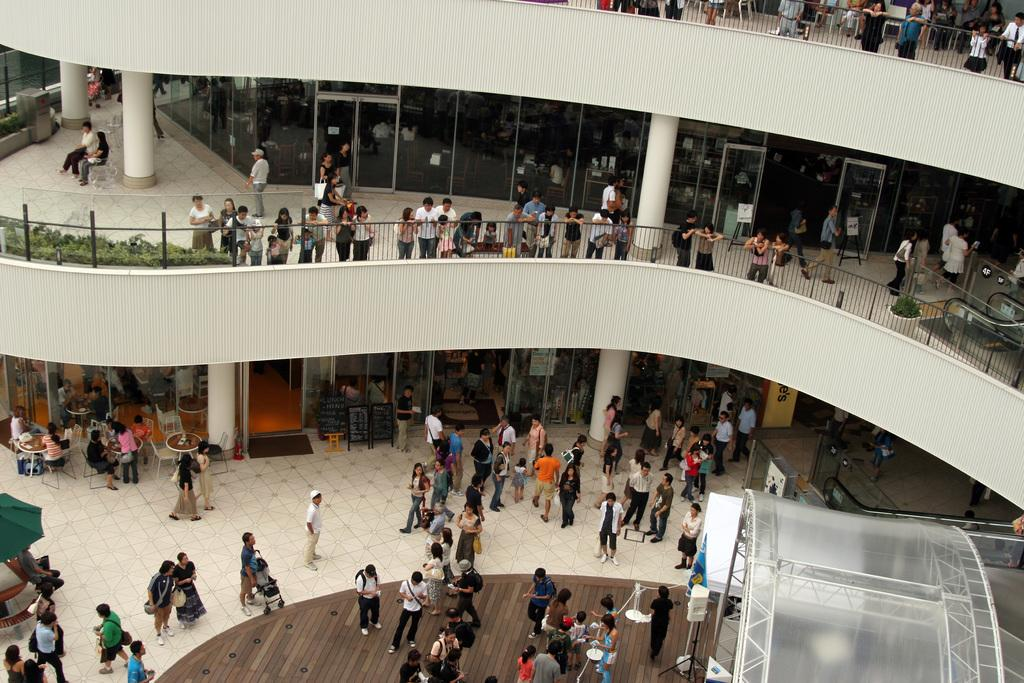How many people are in the image? There is a group of people in the image, but the exact number cannot be determined from the provided facts. What are the people in the image doing? Some people are standing, while others are sitting. What type of vegetation is visible in the image? There are plants visible in the image. What is the color of the plants? The plants are green in color. What type of structure is present in the image? There is a building in the image. What is the color of the building? The building is white in color. What type of skirt is the root of the plant wearing in the image? There is no skirt or root of a plant present in the image. 